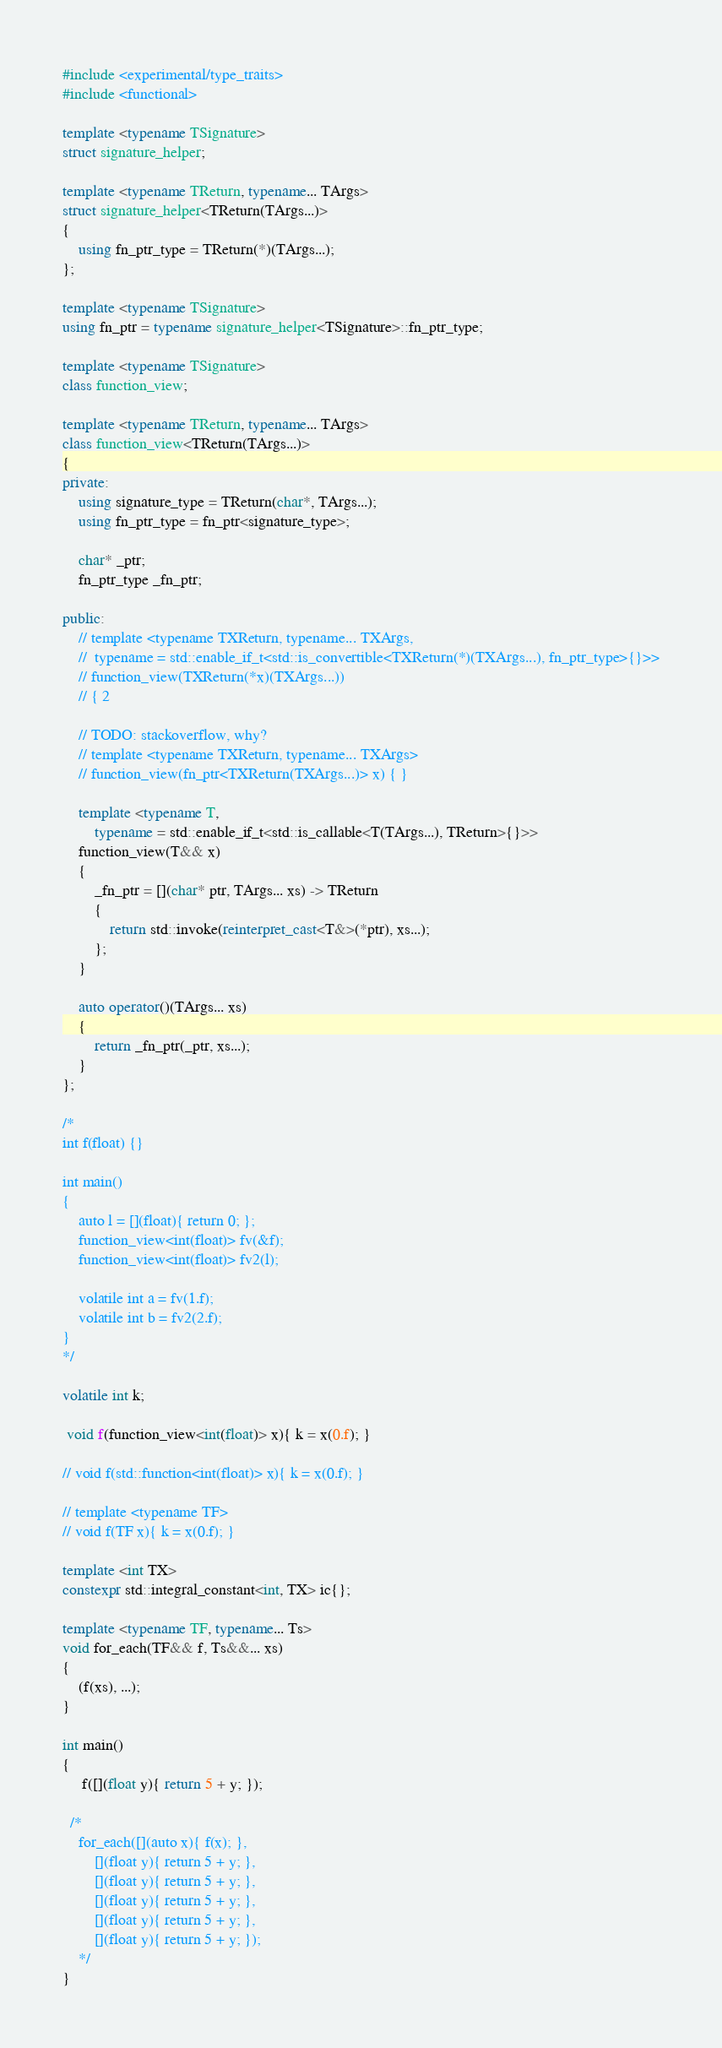<code> <loc_0><loc_0><loc_500><loc_500><_C++_>#include <experimental/type_traits>
#include <functional>

template <typename TSignature>
struct signature_helper;

template <typename TReturn, typename... TArgs>
struct signature_helper<TReturn(TArgs...)>
{
	using fn_ptr_type = TReturn(*)(TArgs...);
};

template <typename TSignature>
using fn_ptr = typename signature_helper<TSignature>::fn_ptr_type;

template <typename TSignature>
class function_view;

template <typename TReturn, typename... TArgs>
class function_view<TReturn(TArgs...)>
{
private:
	using signature_type = TReturn(char*, TArgs...);
	using fn_ptr_type = fn_ptr<signature_type>;
    
    char* _ptr;
    fn_ptr_type _fn_ptr;

public:
	// template <typename TXReturn, typename... TXArgs, 
    // 	typename = std::enable_if_t<std::is_convertible<TXReturn(*)(TXArgs...), fn_ptr_type>{}>>
    // function_view(TXReturn(*x)(TXArgs...)) 
    // { 2

	// TODO: stackoverflow, why?
	// template <typename TXReturn, typename... TXArgs>
    // function_view(fn_ptr<TXReturn(TXArgs...)> x) { }

	template <typename T, 
    	typename = std::enable_if_t<std::is_callable<T(TArgs...), TReturn>{}>>
	function_view(T&& x) 
    {
    	_fn_ptr = [](char* ptr, TArgs... xs) -> TReturn 
        {
        	return std::invoke(reinterpret_cast<T&>(*ptr), xs...);
        };
    }
    
    auto operator()(TArgs... xs) 
    { 
    	return _fn_ptr(_ptr, xs...);
    }
};

/*
int f(float) {}

int main()
{
  	auto l = [](float){ return 0; };
	function_view<int(float)> fv(&f);
  	function_view<int(float)> fv2(l); 
  
  	volatile int a = fv(1.f);
  	volatile int b = fv2(2.f);
}
*/

volatile int k;

 void f(function_view<int(float)> x){ k = x(0.f); }

// void f(std::function<int(float)> x){ k = x(0.f); }

// template <typename TF>
// void f(TF x){ k = x(0.f); }

template <int TX>
constexpr std::integral_constant<int, TX> ic{};

template <typename TF, typename... Ts>
void for_each(TF&& f, Ts&&... xs)
{
	(f(xs), ...);
}

int main()
{
	 f([](float y){ return 5 + y; });
  
  /*
 	for_each([](auto x){ f(x); }, 
		[](float y){ return 5 + y; },
		[](float y){ return 5 + y; },
		[](float y){ return 5 + y; },
		[](float y){ return 5 + y; },
		[](float y){ return 5 + y; });
	*/
}


</code> 